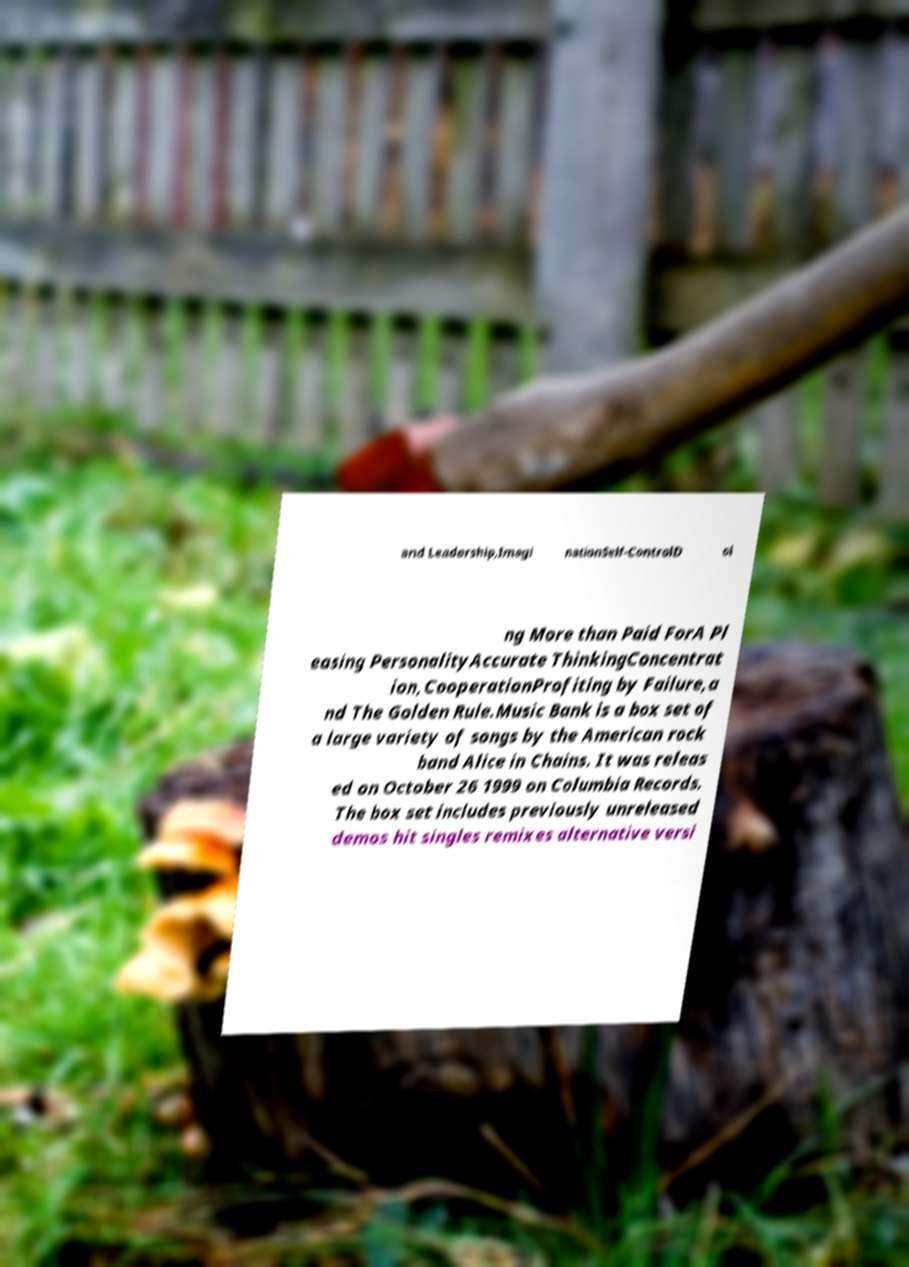Could you extract and type out the text from this image? and Leadership,Imagi nationSelf-ControlD oi ng More than Paid ForA Pl easing PersonalityAccurate ThinkingConcentrat ion,CooperationProfiting by Failure,a nd The Golden Rule.Music Bank is a box set of a large variety of songs by the American rock band Alice in Chains. It was releas ed on October 26 1999 on Columbia Records. The box set includes previously unreleased demos hit singles remixes alternative versi 